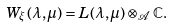Convert formula to latex. <formula><loc_0><loc_0><loc_500><loc_500>W _ { \xi } ( \lambda , \mu ) = L ( \lambda , \mu ) \otimes _ { \mathcal { A } } \mathbb { C } .</formula> 